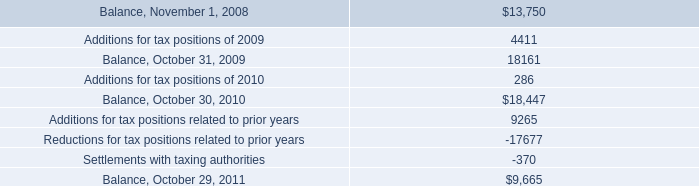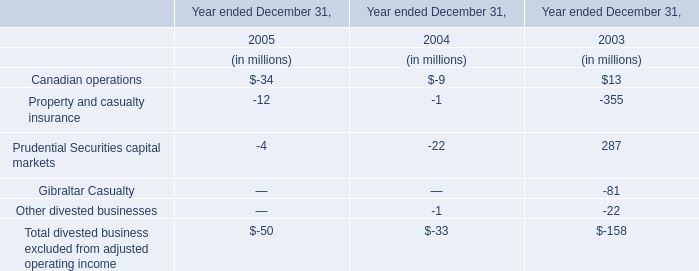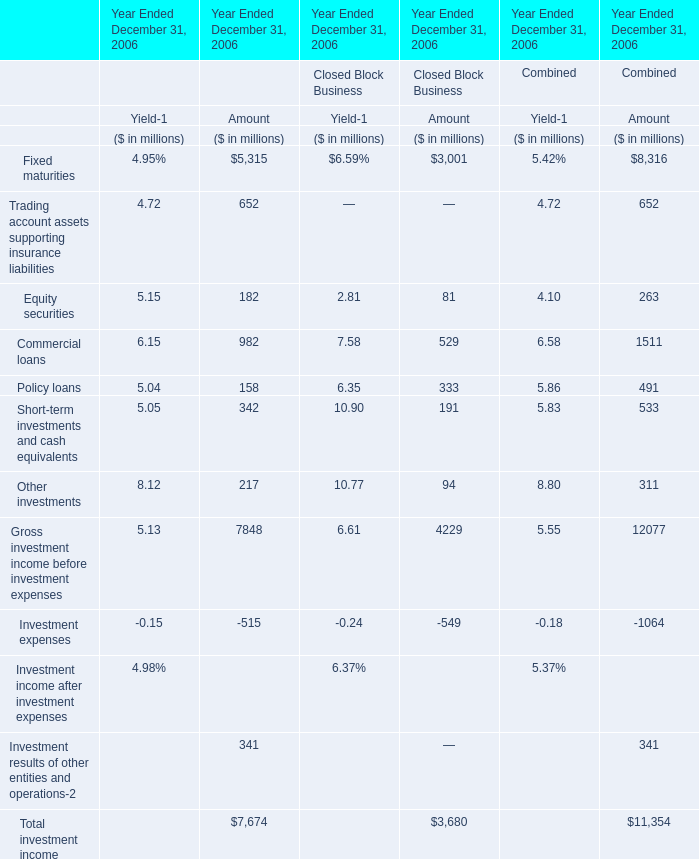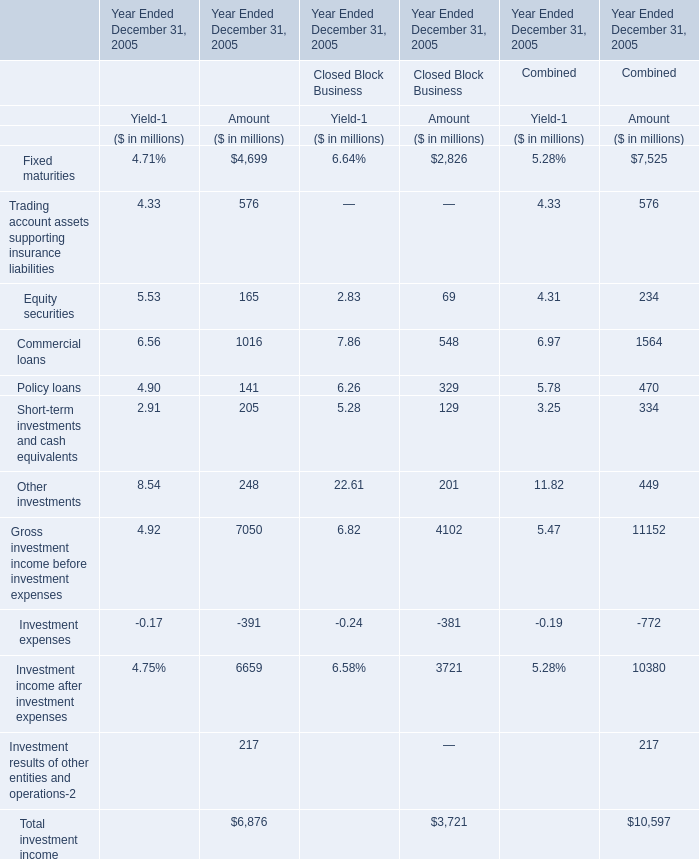What is the proportion of all elements that are greater than 300 to the total amount of elements for Amount of Closed Block Business? 
Computations: (((3001 + 529) + 333) / 3680)
Answer: 1.04973. 